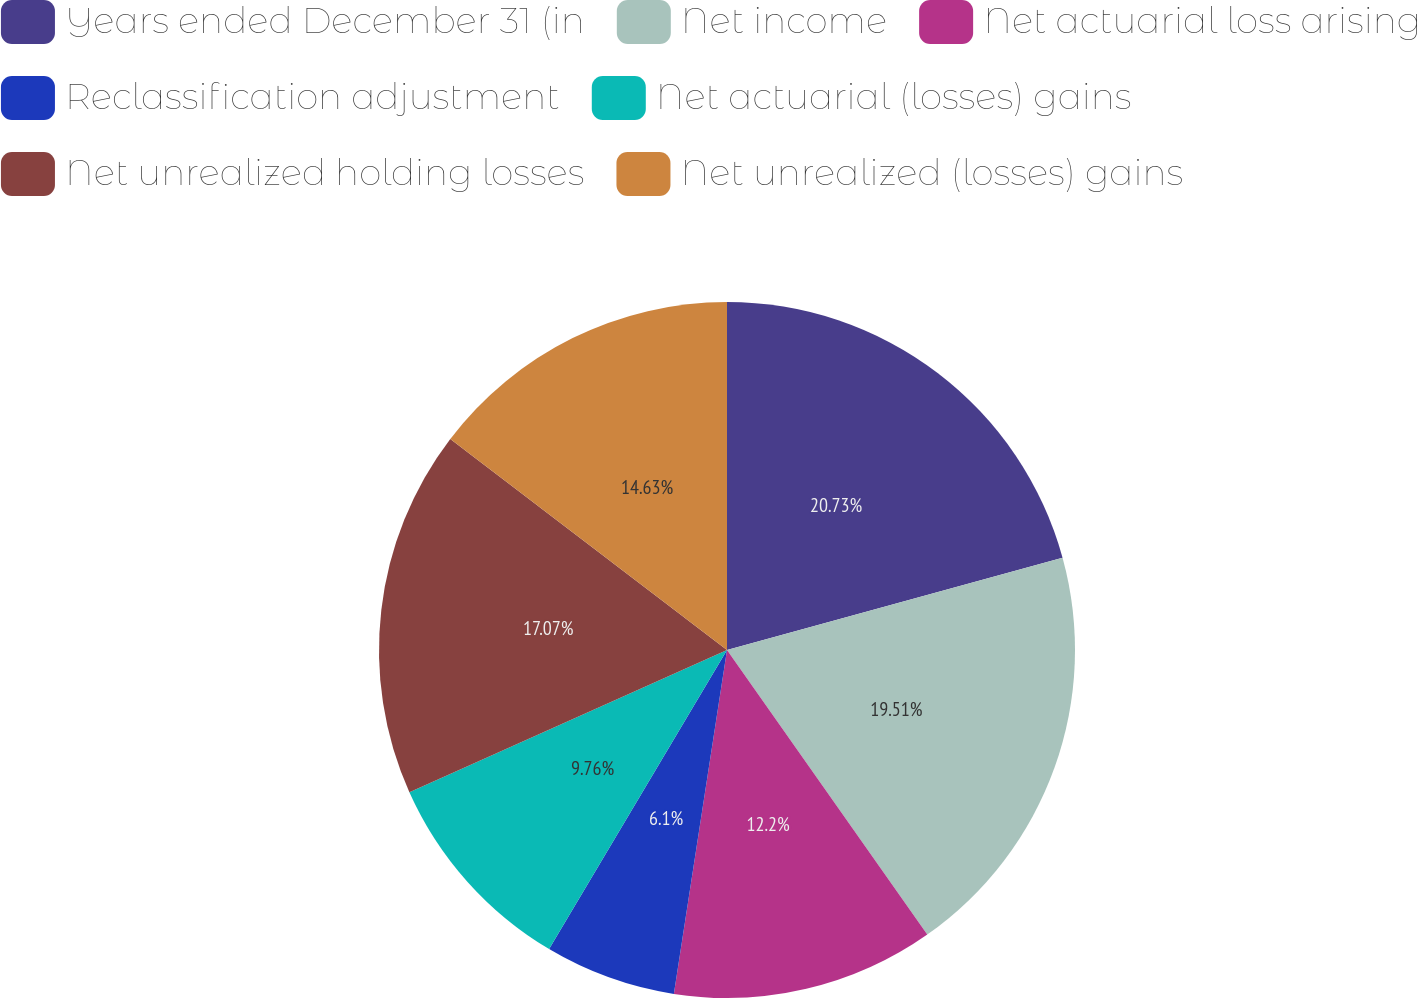Convert chart. <chart><loc_0><loc_0><loc_500><loc_500><pie_chart><fcel>Years ended December 31 (in<fcel>Net income<fcel>Net actuarial loss arising<fcel>Reclassification adjustment<fcel>Net actuarial (losses) gains<fcel>Net unrealized holding losses<fcel>Net unrealized (losses) gains<nl><fcel>20.73%<fcel>19.51%<fcel>12.2%<fcel>6.1%<fcel>9.76%<fcel>17.07%<fcel>14.63%<nl></chart> 